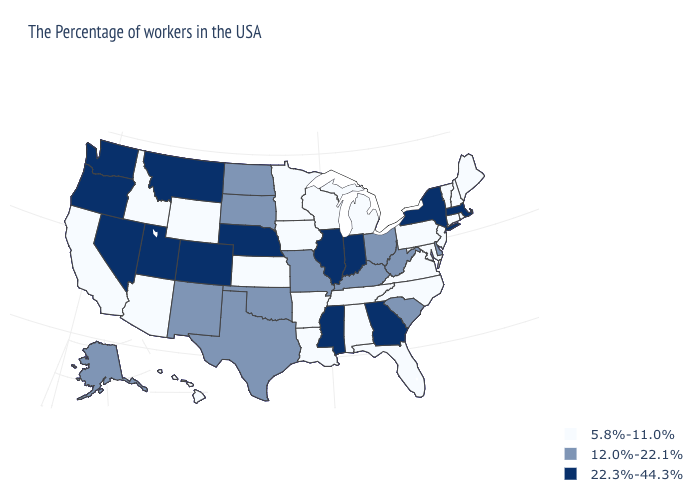What is the value of Hawaii?
Quick response, please. 5.8%-11.0%. What is the highest value in the USA?
Give a very brief answer. 22.3%-44.3%. Does Maryland have a lower value than New Mexico?
Be succinct. Yes. What is the value of Oregon?
Answer briefly. 22.3%-44.3%. Name the states that have a value in the range 12.0%-22.1%?
Answer briefly. Delaware, South Carolina, West Virginia, Ohio, Kentucky, Missouri, Oklahoma, Texas, South Dakota, North Dakota, New Mexico, Alaska. Does the first symbol in the legend represent the smallest category?
Concise answer only. Yes. Which states have the lowest value in the South?
Keep it brief. Maryland, Virginia, North Carolina, Florida, Alabama, Tennessee, Louisiana, Arkansas. What is the value of South Dakota?
Concise answer only. 12.0%-22.1%. Name the states that have a value in the range 22.3%-44.3%?
Give a very brief answer. Massachusetts, New York, Georgia, Indiana, Illinois, Mississippi, Nebraska, Colorado, Utah, Montana, Nevada, Washington, Oregon. Name the states that have a value in the range 22.3%-44.3%?
Answer briefly. Massachusetts, New York, Georgia, Indiana, Illinois, Mississippi, Nebraska, Colorado, Utah, Montana, Nevada, Washington, Oregon. What is the value of Arkansas?
Concise answer only. 5.8%-11.0%. What is the value of New Jersey?
Be succinct. 5.8%-11.0%. Which states have the highest value in the USA?
Quick response, please. Massachusetts, New York, Georgia, Indiana, Illinois, Mississippi, Nebraska, Colorado, Utah, Montana, Nevada, Washington, Oregon. Which states have the lowest value in the West?
Answer briefly. Wyoming, Arizona, Idaho, California, Hawaii. How many symbols are there in the legend?
Give a very brief answer. 3. 